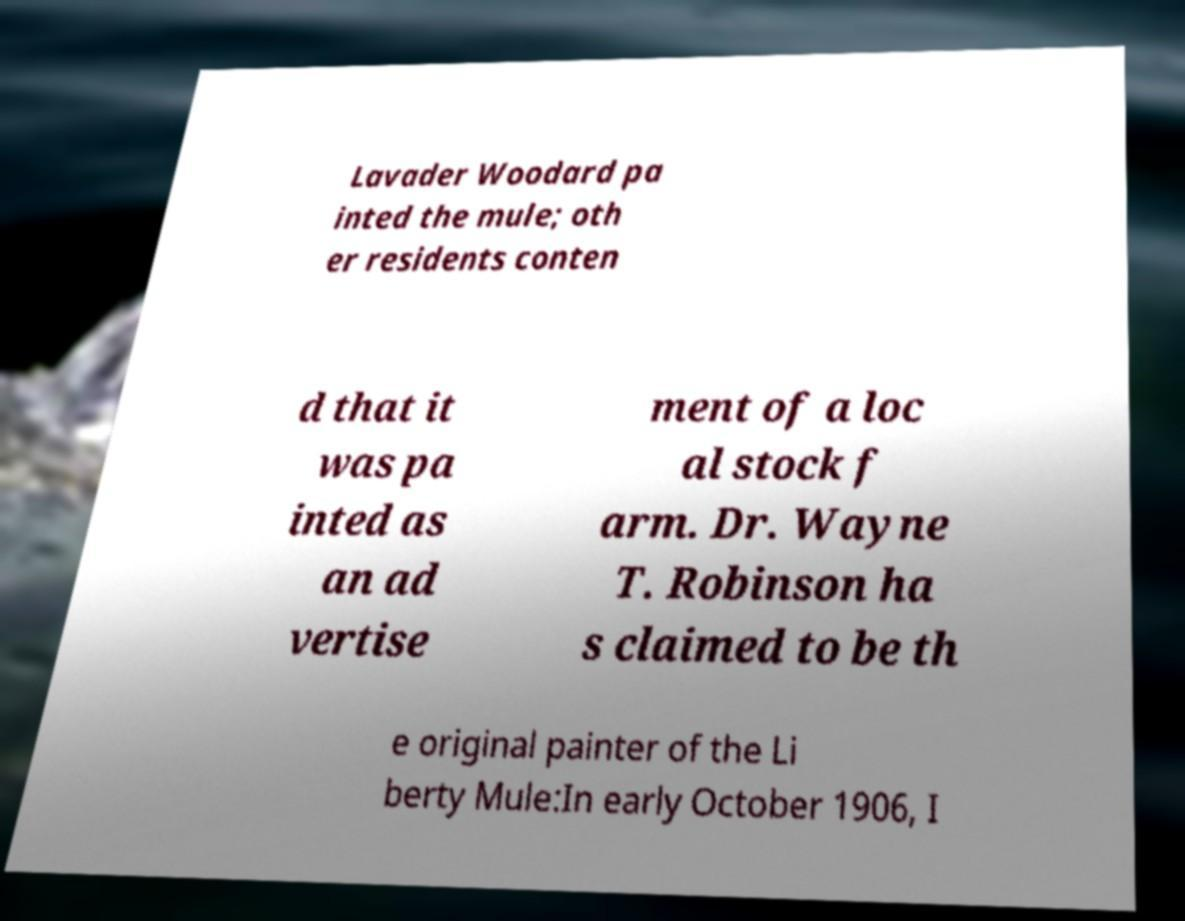Can you accurately transcribe the text from the provided image for me? Lavader Woodard pa inted the mule; oth er residents conten d that it was pa inted as an ad vertise ment of a loc al stock f arm. Dr. Wayne T. Robinson ha s claimed to be th e original painter of the Li berty Mule:In early October 1906, I 